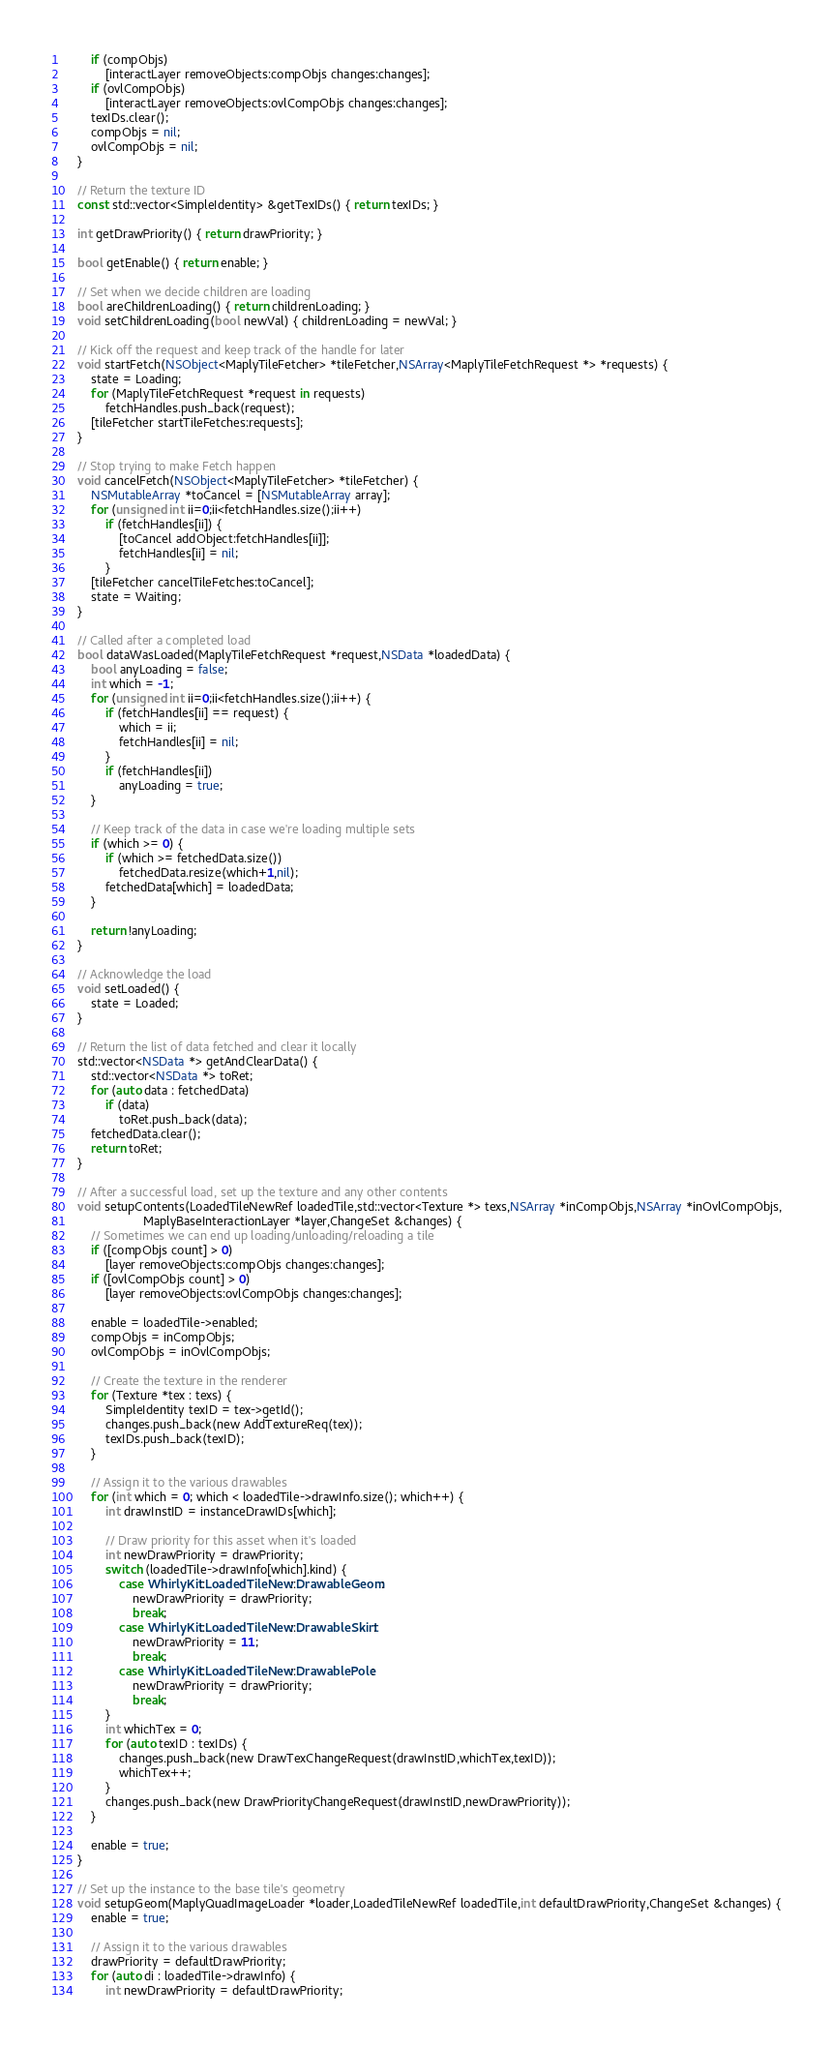Convert code to text. <code><loc_0><loc_0><loc_500><loc_500><_ObjectiveC_>        if (compObjs)
            [interactLayer removeObjects:compObjs changes:changes];
        if (ovlCompObjs)
            [interactLayer removeObjects:ovlCompObjs changes:changes];
        texIDs.clear();
        compObjs = nil;
        ovlCompObjs = nil;
    }
    
    // Return the texture ID
    const std::vector<SimpleIdentity> &getTexIDs() { return texIDs; }
    
    int getDrawPriority() { return drawPriority; }
    
    bool getEnable() { return enable; }
    
    // Set when we decide children are loading
    bool areChildrenLoading() { return childrenLoading; }
    void setChildrenLoading(bool newVal) { childrenLoading = newVal; }
 
    // Kick off the request and keep track of the handle for later
    void startFetch(NSObject<MaplyTileFetcher> *tileFetcher,NSArray<MaplyTileFetchRequest *> *requests) {
        state = Loading;
        for (MaplyTileFetchRequest *request in requests)
            fetchHandles.push_back(request);
        [tileFetcher startTileFetches:requests];
    }

    // Stop trying to make Fetch happen
    void cancelFetch(NSObject<MaplyTileFetcher> *tileFetcher) {
        NSMutableArray *toCancel = [NSMutableArray array];
        for (unsigned int ii=0;ii<fetchHandles.size();ii++)
            if (fetchHandles[ii]) {
                [toCancel addObject:fetchHandles[ii]];
                fetchHandles[ii] = nil;
            }
        [tileFetcher cancelTileFetches:toCancel];
        state = Waiting;
    }
    
    // Called after a completed load
    bool dataWasLoaded(MaplyTileFetchRequest *request,NSData *loadedData) {
        bool anyLoading = false;
        int which = -1;
        for (unsigned int ii=0;ii<fetchHandles.size();ii++) {
            if (fetchHandles[ii] == request) {
                which = ii;
                fetchHandles[ii] = nil;
            }
            if (fetchHandles[ii])
                anyLoading = true;
        }
        
        // Keep track of the data in case we're loading multiple sets
        if (which >= 0) {
            if (which >= fetchedData.size())
                fetchedData.resize(which+1,nil);
            fetchedData[which] = loadedData;
        }
        
        return !anyLoading;
    }

    // Acknowledge the load
    void setLoaded() {
        state = Loaded;
    }
    
    // Return the list of data fetched and clear it locally
    std::vector<NSData *> getAndClearData() {
        std::vector<NSData *> toRet;
        for (auto data : fetchedData)
            if (data)
                toRet.push_back(data);
        fetchedData.clear();
        return toRet;
    }
    
    // After a successful load, set up the texture and any other contents
    void setupContents(LoadedTileNewRef loadedTile,std::vector<Texture *> texs,NSArray *inCompObjs,NSArray *inOvlCompObjs,
                       MaplyBaseInteractionLayer *layer,ChangeSet &changes) {
        // Sometimes we can end up loading/unloading/reloading a tile
        if ([compObjs count] > 0)
            [layer removeObjects:compObjs changes:changes];
        if ([ovlCompObjs count] > 0)
            [layer removeObjects:ovlCompObjs changes:changes];
        
        enable = loadedTile->enabled;
        compObjs = inCompObjs;
        ovlCompObjs = inOvlCompObjs;

        // Create the texture in the renderer
        for (Texture *tex : texs) {
            SimpleIdentity texID = tex->getId();
            changes.push_back(new AddTextureReq(tex));
            texIDs.push_back(texID);
        }

        // Assign it to the various drawables
        for (int which = 0; which < loadedTile->drawInfo.size(); which++) {
            int drawInstID = instanceDrawIDs[which];

            // Draw priority for this asset when it's loaded
            int newDrawPriority = drawPriority;
            switch (loadedTile->drawInfo[which].kind) {
                case WhirlyKit::LoadedTileNew::DrawableGeom:
                    newDrawPriority = drawPriority;
                    break;
                case WhirlyKit::LoadedTileNew::DrawableSkirt:
                    newDrawPriority = 11;
                    break;
                case WhirlyKit::LoadedTileNew::DrawablePole:
                    newDrawPriority = drawPriority;
                    break;
            }
            int whichTex = 0;
            for (auto texID : texIDs) {
                changes.push_back(new DrawTexChangeRequest(drawInstID,whichTex,texID));
                whichTex++;
            }
            changes.push_back(new DrawPriorityChangeRequest(drawInstID,newDrawPriority));
        }

        enable = true;
    }
    
    // Set up the instance to the base tile's geometry
    void setupGeom(MaplyQuadImageLoader *loader,LoadedTileNewRef loadedTile,int defaultDrawPriority,ChangeSet &changes) {
        enable = true;
        
        // Assign it to the various drawables
        drawPriority = defaultDrawPriority;
        for (auto di : loadedTile->drawInfo) {
            int newDrawPriority = defaultDrawPriority;</code> 